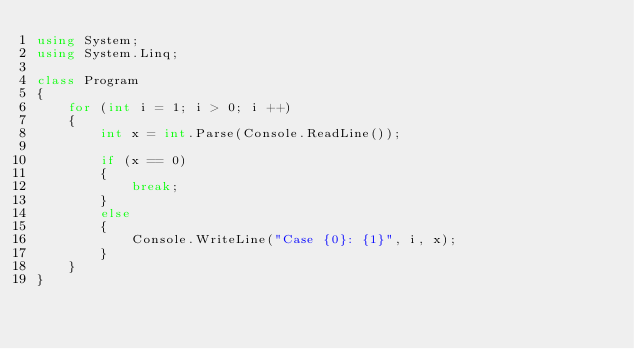Convert code to text. <code><loc_0><loc_0><loc_500><loc_500><_C#_>using System;
using System.Linq;

class Program
{
    for (int i = 1; i > 0; i ++)
    {
        int x = int.Parse(Console.ReadLine());
        
        if (x == 0)
        {
            break;
        }
        else
        {
            Console.WriteLine("Case {0}: {1}", i, x);
        }
    }
}
</code> 